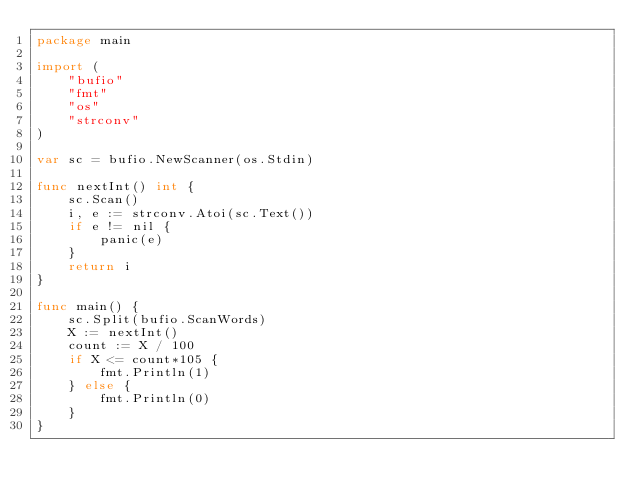<code> <loc_0><loc_0><loc_500><loc_500><_Go_>package main

import (
	"bufio"
	"fmt"
	"os"
	"strconv"
)

var sc = bufio.NewScanner(os.Stdin)

func nextInt() int {
	sc.Scan()
	i, e := strconv.Atoi(sc.Text())
	if e != nil {
		panic(e)
	}
	return i
}

func main() {
	sc.Split(bufio.ScanWords)
	X := nextInt()
	count := X / 100
	if X <= count*105 {
		fmt.Println(1)
	} else {
		fmt.Println(0)
	}
}
</code> 